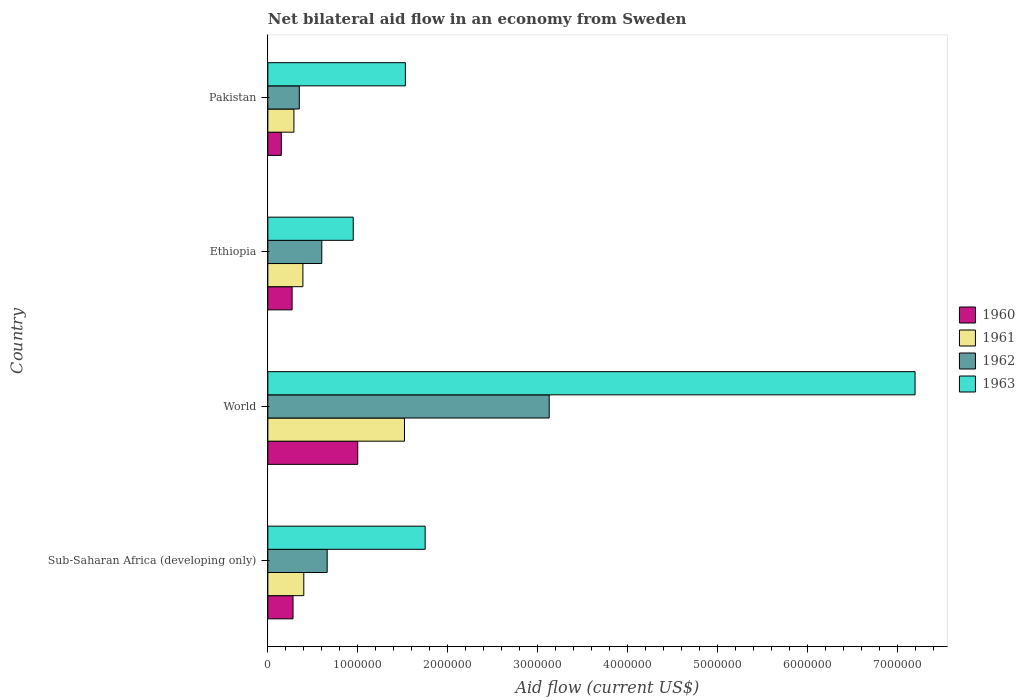How many bars are there on the 4th tick from the bottom?
Offer a very short reply. 4. What is the net bilateral aid flow in 1963 in Pakistan?
Your answer should be compact. 1.53e+06. Across all countries, what is the maximum net bilateral aid flow in 1962?
Your answer should be very brief. 3.13e+06. Across all countries, what is the minimum net bilateral aid flow in 1963?
Keep it short and to the point. 9.50e+05. In which country was the net bilateral aid flow in 1961 minimum?
Provide a succinct answer. Pakistan. What is the total net bilateral aid flow in 1963 in the graph?
Your answer should be compact. 1.14e+07. What is the difference between the net bilateral aid flow in 1963 in Ethiopia and that in Pakistan?
Offer a very short reply. -5.80e+05. What is the average net bilateral aid flow in 1962 per country?
Make the answer very short. 1.18e+06. What is the difference between the net bilateral aid flow in 1961 and net bilateral aid flow in 1963 in Pakistan?
Give a very brief answer. -1.24e+06. In how many countries, is the net bilateral aid flow in 1961 greater than 5000000 US$?
Your response must be concise. 0. What is the ratio of the net bilateral aid flow in 1960 in Pakistan to that in World?
Offer a terse response. 0.15. Is the net bilateral aid flow in 1963 in Pakistan less than that in Sub-Saharan Africa (developing only)?
Provide a short and direct response. Yes. What is the difference between the highest and the second highest net bilateral aid flow in 1961?
Your response must be concise. 1.12e+06. What is the difference between the highest and the lowest net bilateral aid flow in 1961?
Give a very brief answer. 1.23e+06. Is it the case that in every country, the sum of the net bilateral aid flow in 1961 and net bilateral aid flow in 1963 is greater than the net bilateral aid flow in 1962?
Offer a terse response. Yes. How many bars are there?
Keep it short and to the point. 16. Are all the bars in the graph horizontal?
Your answer should be compact. Yes. How many countries are there in the graph?
Give a very brief answer. 4. What is the difference between two consecutive major ticks on the X-axis?
Provide a short and direct response. 1.00e+06. Does the graph contain any zero values?
Make the answer very short. No. How many legend labels are there?
Ensure brevity in your answer.  4. How are the legend labels stacked?
Provide a succinct answer. Vertical. What is the title of the graph?
Your response must be concise. Net bilateral aid flow in an economy from Sweden. What is the label or title of the X-axis?
Your answer should be very brief. Aid flow (current US$). What is the label or title of the Y-axis?
Make the answer very short. Country. What is the Aid flow (current US$) in 1963 in Sub-Saharan Africa (developing only)?
Make the answer very short. 1.75e+06. What is the Aid flow (current US$) in 1960 in World?
Provide a short and direct response. 1.00e+06. What is the Aid flow (current US$) of 1961 in World?
Offer a very short reply. 1.52e+06. What is the Aid flow (current US$) in 1962 in World?
Your answer should be compact. 3.13e+06. What is the Aid flow (current US$) in 1963 in World?
Offer a terse response. 7.20e+06. What is the Aid flow (current US$) in 1963 in Ethiopia?
Give a very brief answer. 9.50e+05. What is the Aid flow (current US$) in 1961 in Pakistan?
Provide a short and direct response. 2.90e+05. What is the Aid flow (current US$) in 1962 in Pakistan?
Provide a succinct answer. 3.50e+05. What is the Aid flow (current US$) in 1963 in Pakistan?
Give a very brief answer. 1.53e+06. Across all countries, what is the maximum Aid flow (current US$) of 1961?
Ensure brevity in your answer.  1.52e+06. Across all countries, what is the maximum Aid flow (current US$) in 1962?
Make the answer very short. 3.13e+06. Across all countries, what is the maximum Aid flow (current US$) in 1963?
Keep it short and to the point. 7.20e+06. Across all countries, what is the minimum Aid flow (current US$) in 1962?
Offer a terse response. 3.50e+05. Across all countries, what is the minimum Aid flow (current US$) in 1963?
Your response must be concise. 9.50e+05. What is the total Aid flow (current US$) of 1960 in the graph?
Offer a very short reply. 1.70e+06. What is the total Aid flow (current US$) in 1961 in the graph?
Give a very brief answer. 2.60e+06. What is the total Aid flow (current US$) of 1962 in the graph?
Make the answer very short. 4.74e+06. What is the total Aid flow (current US$) in 1963 in the graph?
Make the answer very short. 1.14e+07. What is the difference between the Aid flow (current US$) of 1960 in Sub-Saharan Africa (developing only) and that in World?
Your response must be concise. -7.20e+05. What is the difference between the Aid flow (current US$) in 1961 in Sub-Saharan Africa (developing only) and that in World?
Keep it short and to the point. -1.12e+06. What is the difference between the Aid flow (current US$) in 1962 in Sub-Saharan Africa (developing only) and that in World?
Your answer should be very brief. -2.47e+06. What is the difference between the Aid flow (current US$) in 1963 in Sub-Saharan Africa (developing only) and that in World?
Your response must be concise. -5.45e+06. What is the difference between the Aid flow (current US$) of 1960 in Sub-Saharan Africa (developing only) and that in Ethiopia?
Provide a succinct answer. 10000. What is the difference between the Aid flow (current US$) of 1961 in Sub-Saharan Africa (developing only) and that in Ethiopia?
Give a very brief answer. 10000. What is the difference between the Aid flow (current US$) of 1962 in Sub-Saharan Africa (developing only) and that in Pakistan?
Ensure brevity in your answer.  3.10e+05. What is the difference between the Aid flow (current US$) in 1960 in World and that in Ethiopia?
Keep it short and to the point. 7.30e+05. What is the difference between the Aid flow (current US$) in 1961 in World and that in Ethiopia?
Your answer should be very brief. 1.13e+06. What is the difference between the Aid flow (current US$) in 1962 in World and that in Ethiopia?
Ensure brevity in your answer.  2.53e+06. What is the difference between the Aid flow (current US$) in 1963 in World and that in Ethiopia?
Your response must be concise. 6.25e+06. What is the difference between the Aid flow (current US$) of 1960 in World and that in Pakistan?
Offer a very short reply. 8.50e+05. What is the difference between the Aid flow (current US$) in 1961 in World and that in Pakistan?
Offer a very short reply. 1.23e+06. What is the difference between the Aid flow (current US$) of 1962 in World and that in Pakistan?
Your response must be concise. 2.78e+06. What is the difference between the Aid flow (current US$) in 1963 in World and that in Pakistan?
Offer a terse response. 5.67e+06. What is the difference between the Aid flow (current US$) in 1960 in Ethiopia and that in Pakistan?
Offer a very short reply. 1.20e+05. What is the difference between the Aid flow (current US$) of 1961 in Ethiopia and that in Pakistan?
Your response must be concise. 1.00e+05. What is the difference between the Aid flow (current US$) in 1963 in Ethiopia and that in Pakistan?
Give a very brief answer. -5.80e+05. What is the difference between the Aid flow (current US$) of 1960 in Sub-Saharan Africa (developing only) and the Aid flow (current US$) of 1961 in World?
Keep it short and to the point. -1.24e+06. What is the difference between the Aid flow (current US$) in 1960 in Sub-Saharan Africa (developing only) and the Aid flow (current US$) in 1962 in World?
Your answer should be very brief. -2.85e+06. What is the difference between the Aid flow (current US$) of 1960 in Sub-Saharan Africa (developing only) and the Aid flow (current US$) of 1963 in World?
Provide a succinct answer. -6.92e+06. What is the difference between the Aid flow (current US$) of 1961 in Sub-Saharan Africa (developing only) and the Aid flow (current US$) of 1962 in World?
Provide a succinct answer. -2.73e+06. What is the difference between the Aid flow (current US$) in 1961 in Sub-Saharan Africa (developing only) and the Aid flow (current US$) in 1963 in World?
Ensure brevity in your answer.  -6.80e+06. What is the difference between the Aid flow (current US$) in 1962 in Sub-Saharan Africa (developing only) and the Aid flow (current US$) in 1963 in World?
Your response must be concise. -6.54e+06. What is the difference between the Aid flow (current US$) of 1960 in Sub-Saharan Africa (developing only) and the Aid flow (current US$) of 1962 in Ethiopia?
Your answer should be very brief. -3.20e+05. What is the difference between the Aid flow (current US$) of 1960 in Sub-Saharan Africa (developing only) and the Aid flow (current US$) of 1963 in Ethiopia?
Your response must be concise. -6.70e+05. What is the difference between the Aid flow (current US$) of 1961 in Sub-Saharan Africa (developing only) and the Aid flow (current US$) of 1962 in Ethiopia?
Make the answer very short. -2.00e+05. What is the difference between the Aid flow (current US$) in 1961 in Sub-Saharan Africa (developing only) and the Aid flow (current US$) in 1963 in Ethiopia?
Provide a short and direct response. -5.50e+05. What is the difference between the Aid flow (current US$) of 1962 in Sub-Saharan Africa (developing only) and the Aid flow (current US$) of 1963 in Ethiopia?
Provide a short and direct response. -2.90e+05. What is the difference between the Aid flow (current US$) in 1960 in Sub-Saharan Africa (developing only) and the Aid flow (current US$) in 1961 in Pakistan?
Offer a very short reply. -10000. What is the difference between the Aid flow (current US$) of 1960 in Sub-Saharan Africa (developing only) and the Aid flow (current US$) of 1963 in Pakistan?
Offer a very short reply. -1.25e+06. What is the difference between the Aid flow (current US$) in 1961 in Sub-Saharan Africa (developing only) and the Aid flow (current US$) in 1963 in Pakistan?
Your answer should be compact. -1.13e+06. What is the difference between the Aid flow (current US$) in 1962 in Sub-Saharan Africa (developing only) and the Aid flow (current US$) in 1963 in Pakistan?
Offer a terse response. -8.70e+05. What is the difference between the Aid flow (current US$) in 1960 in World and the Aid flow (current US$) in 1961 in Ethiopia?
Make the answer very short. 6.10e+05. What is the difference between the Aid flow (current US$) in 1960 in World and the Aid flow (current US$) in 1962 in Ethiopia?
Your answer should be very brief. 4.00e+05. What is the difference between the Aid flow (current US$) of 1961 in World and the Aid flow (current US$) of 1962 in Ethiopia?
Your answer should be compact. 9.20e+05. What is the difference between the Aid flow (current US$) in 1961 in World and the Aid flow (current US$) in 1963 in Ethiopia?
Provide a short and direct response. 5.70e+05. What is the difference between the Aid flow (current US$) in 1962 in World and the Aid flow (current US$) in 1963 in Ethiopia?
Your answer should be compact. 2.18e+06. What is the difference between the Aid flow (current US$) in 1960 in World and the Aid flow (current US$) in 1961 in Pakistan?
Ensure brevity in your answer.  7.10e+05. What is the difference between the Aid flow (current US$) of 1960 in World and the Aid flow (current US$) of 1962 in Pakistan?
Offer a terse response. 6.50e+05. What is the difference between the Aid flow (current US$) of 1960 in World and the Aid flow (current US$) of 1963 in Pakistan?
Ensure brevity in your answer.  -5.30e+05. What is the difference between the Aid flow (current US$) in 1961 in World and the Aid flow (current US$) in 1962 in Pakistan?
Your response must be concise. 1.17e+06. What is the difference between the Aid flow (current US$) in 1961 in World and the Aid flow (current US$) in 1963 in Pakistan?
Keep it short and to the point. -10000. What is the difference between the Aid flow (current US$) of 1962 in World and the Aid flow (current US$) of 1963 in Pakistan?
Ensure brevity in your answer.  1.60e+06. What is the difference between the Aid flow (current US$) in 1960 in Ethiopia and the Aid flow (current US$) in 1963 in Pakistan?
Offer a terse response. -1.26e+06. What is the difference between the Aid flow (current US$) in 1961 in Ethiopia and the Aid flow (current US$) in 1963 in Pakistan?
Provide a succinct answer. -1.14e+06. What is the difference between the Aid flow (current US$) of 1962 in Ethiopia and the Aid flow (current US$) of 1963 in Pakistan?
Make the answer very short. -9.30e+05. What is the average Aid flow (current US$) in 1960 per country?
Offer a very short reply. 4.25e+05. What is the average Aid flow (current US$) in 1961 per country?
Ensure brevity in your answer.  6.50e+05. What is the average Aid flow (current US$) in 1962 per country?
Offer a very short reply. 1.18e+06. What is the average Aid flow (current US$) in 1963 per country?
Ensure brevity in your answer.  2.86e+06. What is the difference between the Aid flow (current US$) of 1960 and Aid flow (current US$) of 1961 in Sub-Saharan Africa (developing only)?
Provide a succinct answer. -1.20e+05. What is the difference between the Aid flow (current US$) in 1960 and Aid flow (current US$) in 1962 in Sub-Saharan Africa (developing only)?
Your answer should be compact. -3.80e+05. What is the difference between the Aid flow (current US$) in 1960 and Aid flow (current US$) in 1963 in Sub-Saharan Africa (developing only)?
Provide a short and direct response. -1.47e+06. What is the difference between the Aid flow (current US$) of 1961 and Aid flow (current US$) of 1963 in Sub-Saharan Africa (developing only)?
Offer a very short reply. -1.35e+06. What is the difference between the Aid flow (current US$) in 1962 and Aid flow (current US$) in 1963 in Sub-Saharan Africa (developing only)?
Offer a very short reply. -1.09e+06. What is the difference between the Aid flow (current US$) of 1960 and Aid flow (current US$) of 1961 in World?
Provide a short and direct response. -5.20e+05. What is the difference between the Aid flow (current US$) in 1960 and Aid flow (current US$) in 1962 in World?
Your answer should be compact. -2.13e+06. What is the difference between the Aid flow (current US$) in 1960 and Aid flow (current US$) in 1963 in World?
Your answer should be very brief. -6.20e+06. What is the difference between the Aid flow (current US$) of 1961 and Aid flow (current US$) of 1962 in World?
Give a very brief answer. -1.61e+06. What is the difference between the Aid flow (current US$) in 1961 and Aid flow (current US$) in 1963 in World?
Offer a very short reply. -5.68e+06. What is the difference between the Aid flow (current US$) of 1962 and Aid flow (current US$) of 1963 in World?
Provide a succinct answer. -4.07e+06. What is the difference between the Aid flow (current US$) in 1960 and Aid flow (current US$) in 1961 in Ethiopia?
Your answer should be very brief. -1.20e+05. What is the difference between the Aid flow (current US$) in 1960 and Aid flow (current US$) in 1962 in Ethiopia?
Provide a short and direct response. -3.30e+05. What is the difference between the Aid flow (current US$) in 1960 and Aid flow (current US$) in 1963 in Ethiopia?
Your response must be concise. -6.80e+05. What is the difference between the Aid flow (current US$) of 1961 and Aid flow (current US$) of 1963 in Ethiopia?
Offer a terse response. -5.60e+05. What is the difference between the Aid flow (current US$) in 1962 and Aid flow (current US$) in 1963 in Ethiopia?
Offer a very short reply. -3.50e+05. What is the difference between the Aid flow (current US$) of 1960 and Aid flow (current US$) of 1961 in Pakistan?
Your answer should be very brief. -1.40e+05. What is the difference between the Aid flow (current US$) in 1960 and Aid flow (current US$) in 1962 in Pakistan?
Provide a short and direct response. -2.00e+05. What is the difference between the Aid flow (current US$) of 1960 and Aid flow (current US$) of 1963 in Pakistan?
Provide a short and direct response. -1.38e+06. What is the difference between the Aid flow (current US$) in 1961 and Aid flow (current US$) in 1963 in Pakistan?
Make the answer very short. -1.24e+06. What is the difference between the Aid flow (current US$) in 1962 and Aid flow (current US$) in 1963 in Pakistan?
Provide a succinct answer. -1.18e+06. What is the ratio of the Aid flow (current US$) of 1960 in Sub-Saharan Africa (developing only) to that in World?
Give a very brief answer. 0.28. What is the ratio of the Aid flow (current US$) in 1961 in Sub-Saharan Africa (developing only) to that in World?
Your answer should be compact. 0.26. What is the ratio of the Aid flow (current US$) of 1962 in Sub-Saharan Africa (developing only) to that in World?
Provide a succinct answer. 0.21. What is the ratio of the Aid flow (current US$) in 1963 in Sub-Saharan Africa (developing only) to that in World?
Provide a succinct answer. 0.24. What is the ratio of the Aid flow (current US$) of 1960 in Sub-Saharan Africa (developing only) to that in Ethiopia?
Offer a terse response. 1.04. What is the ratio of the Aid flow (current US$) in 1961 in Sub-Saharan Africa (developing only) to that in Ethiopia?
Give a very brief answer. 1.03. What is the ratio of the Aid flow (current US$) of 1962 in Sub-Saharan Africa (developing only) to that in Ethiopia?
Keep it short and to the point. 1.1. What is the ratio of the Aid flow (current US$) in 1963 in Sub-Saharan Africa (developing only) to that in Ethiopia?
Provide a short and direct response. 1.84. What is the ratio of the Aid flow (current US$) of 1960 in Sub-Saharan Africa (developing only) to that in Pakistan?
Provide a short and direct response. 1.87. What is the ratio of the Aid flow (current US$) of 1961 in Sub-Saharan Africa (developing only) to that in Pakistan?
Provide a succinct answer. 1.38. What is the ratio of the Aid flow (current US$) in 1962 in Sub-Saharan Africa (developing only) to that in Pakistan?
Provide a succinct answer. 1.89. What is the ratio of the Aid flow (current US$) of 1963 in Sub-Saharan Africa (developing only) to that in Pakistan?
Offer a very short reply. 1.14. What is the ratio of the Aid flow (current US$) of 1960 in World to that in Ethiopia?
Your answer should be very brief. 3.7. What is the ratio of the Aid flow (current US$) of 1961 in World to that in Ethiopia?
Provide a short and direct response. 3.9. What is the ratio of the Aid flow (current US$) in 1962 in World to that in Ethiopia?
Give a very brief answer. 5.22. What is the ratio of the Aid flow (current US$) of 1963 in World to that in Ethiopia?
Ensure brevity in your answer.  7.58. What is the ratio of the Aid flow (current US$) in 1961 in World to that in Pakistan?
Ensure brevity in your answer.  5.24. What is the ratio of the Aid flow (current US$) in 1962 in World to that in Pakistan?
Your answer should be very brief. 8.94. What is the ratio of the Aid flow (current US$) in 1963 in World to that in Pakistan?
Provide a succinct answer. 4.71. What is the ratio of the Aid flow (current US$) in 1961 in Ethiopia to that in Pakistan?
Your answer should be very brief. 1.34. What is the ratio of the Aid flow (current US$) of 1962 in Ethiopia to that in Pakistan?
Provide a short and direct response. 1.71. What is the ratio of the Aid flow (current US$) of 1963 in Ethiopia to that in Pakistan?
Provide a succinct answer. 0.62. What is the difference between the highest and the second highest Aid flow (current US$) in 1960?
Ensure brevity in your answer.  7.20e+05. What is the difference between the highest and the second highest Aid flow (current US$) of 1961?
Provide a short and direct response. 1.12e+06. What is the difference between the highest and the second highest Aid flow (current US$) of 1962?
Give a very brief answer. 2.47e+06. What is the difference between the highest and the second highest Aid flow (current US$) of 1963?
Keep it short and to the point. 5.45e+06. What is the difference between the highest and the lowest Aid flow (current US$) of 1960?
Offer a terse response. 8.50e+05. What is the difference between the highest and the lowest Aid flow (current US$) of 1961?
Offer a very short reply. 1.23e+06. What is the difference between the highest and the lowest Aid flow (current US$) of 1962?
Provide a short and direct response. 2.78e+06. What is the difference between the highest and the lowest Aid flow (current US$) in 1963?
Make the answer very short. 6.25e+06. 